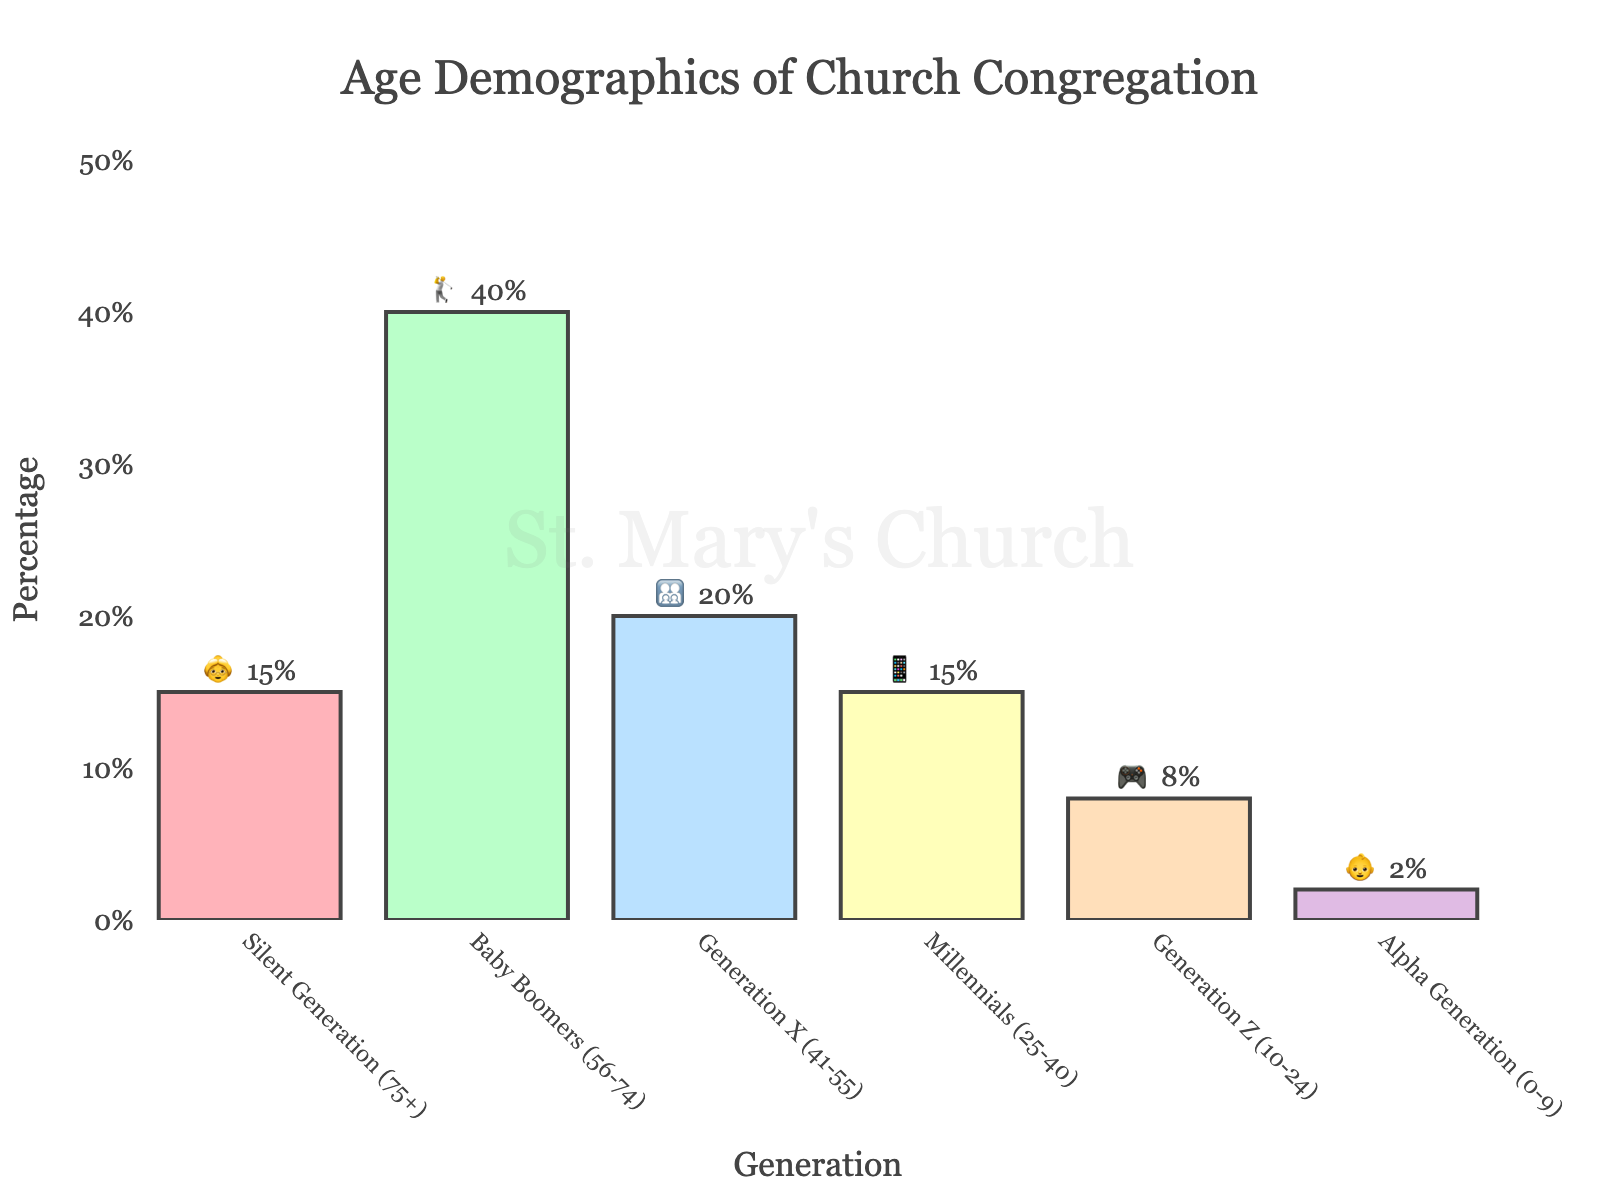What's the title of the chart? The title is located at the top of the chart and reads "Age Demographics of Church Congregation" in a large, readable font.
Answer: Age Demographics of Church Congregation Which generation has the highest percentage in the congregation? By looking at the bar heights and their corresponding annotations, the "Baby Boomers (56-74)" generation has the highest percentage, marked with 40%.
Answer: Baby Boomers (56-74) How many generations are depicted in the chart? The x-axis of the chart lists all the generations, and there are 6 different categories visible.
Answer: 6 What is the combined percentage of Millennials 📱 and Generation Z 🎮? The percentage of Millennials is 15%, and the percentage of Generation Z is 8%. Adding these together results in 23%.
Answer: 23% Which generation has the lowest representation in the congregation? By comparing the bar heights and annotations, the "Alpha Generation (0-9)" with 2% has the lowest percentage among all the generations.
Answer: Alpha Generation (0-9) How much more represented are Baby Boomers 🏌️ than Generation X 👨‍👩‍👧‍👦? The Baby Boomers are at 40% while Generation X is at 20%. The difference is 40% - 20% = 20%.
Answer: 20% What's the total percentage for Silent Generation 👵, Millennials 📱, and Generation Z 🎮? Their percentages are 15%, 15%, and 8% respectively. Adding these together results in 15% + 15% + 8% = 38%.
Answer: 38% Which generation accounts for twice the percentage of the Generation Z 🎮? The Generation Z has 8%, so the generation with twice this amount is 16%. Only Generation X 👨‍👩‍👧‍👦 with 20% fits the criteria as it's close to the exact double.
Answer: Generation X (41-55) Compare the combined percentage of all generations below 40 years old with the Baby Boomers 🏌️. Generations below 40: Millennials (15%) + Generation Z (8%) + Alpha Generation (2%) = 25%. Baby Boomers stand at 40%. Therefore, Baby Boomers have a higher percentage.
Answer: Baby Boomers (56-74) are higher What symbol represents the Alpha Generation? The symbol is visible in the annotations for Alpha Generation (0-9) and is an emoji of a baby.
Answer: 👶 